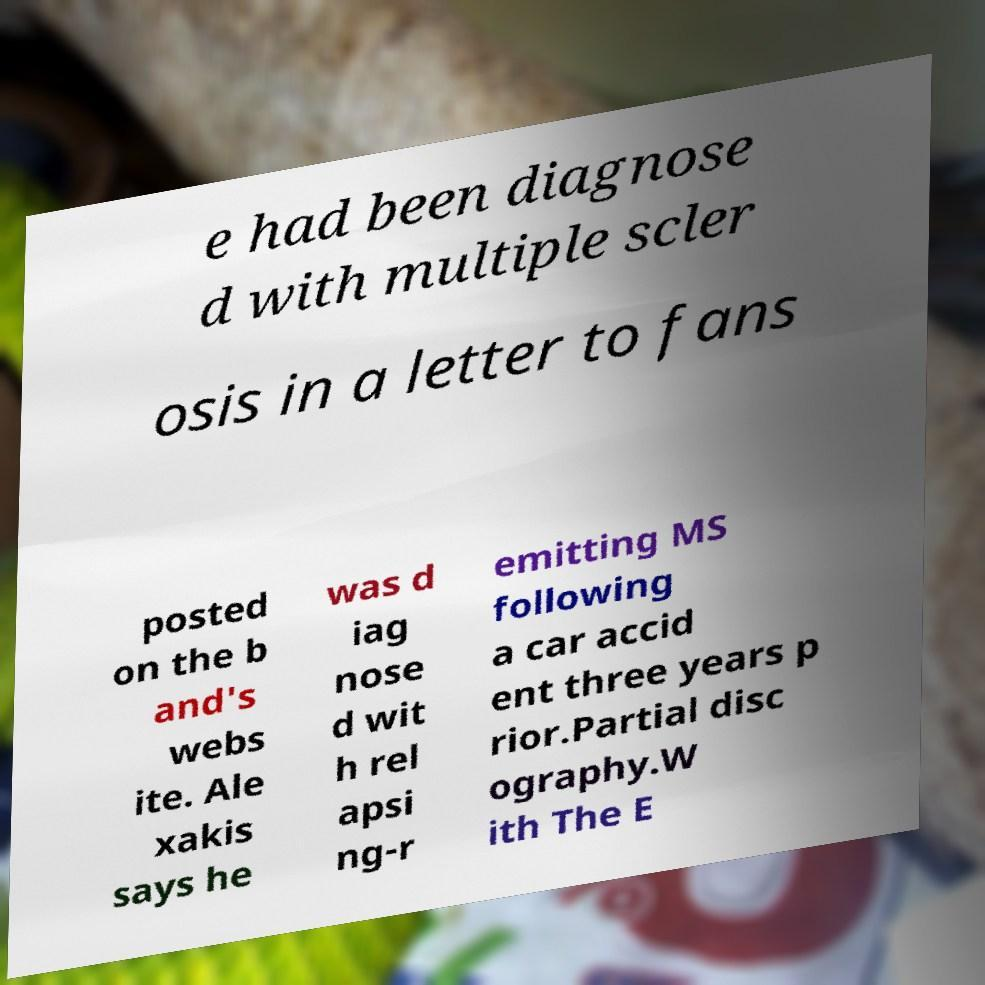What messages or text are displayed in this image? I need them in a readable, typed format. e had been diagnose d with multiple scler osis in a letter to fans posted on the b and's webs ite. Ale xakis says he was d iag nose d wit h rel apsi ng-r emitting MS following a car accid ent three years p rior.Partial disc ography.W ith The E 